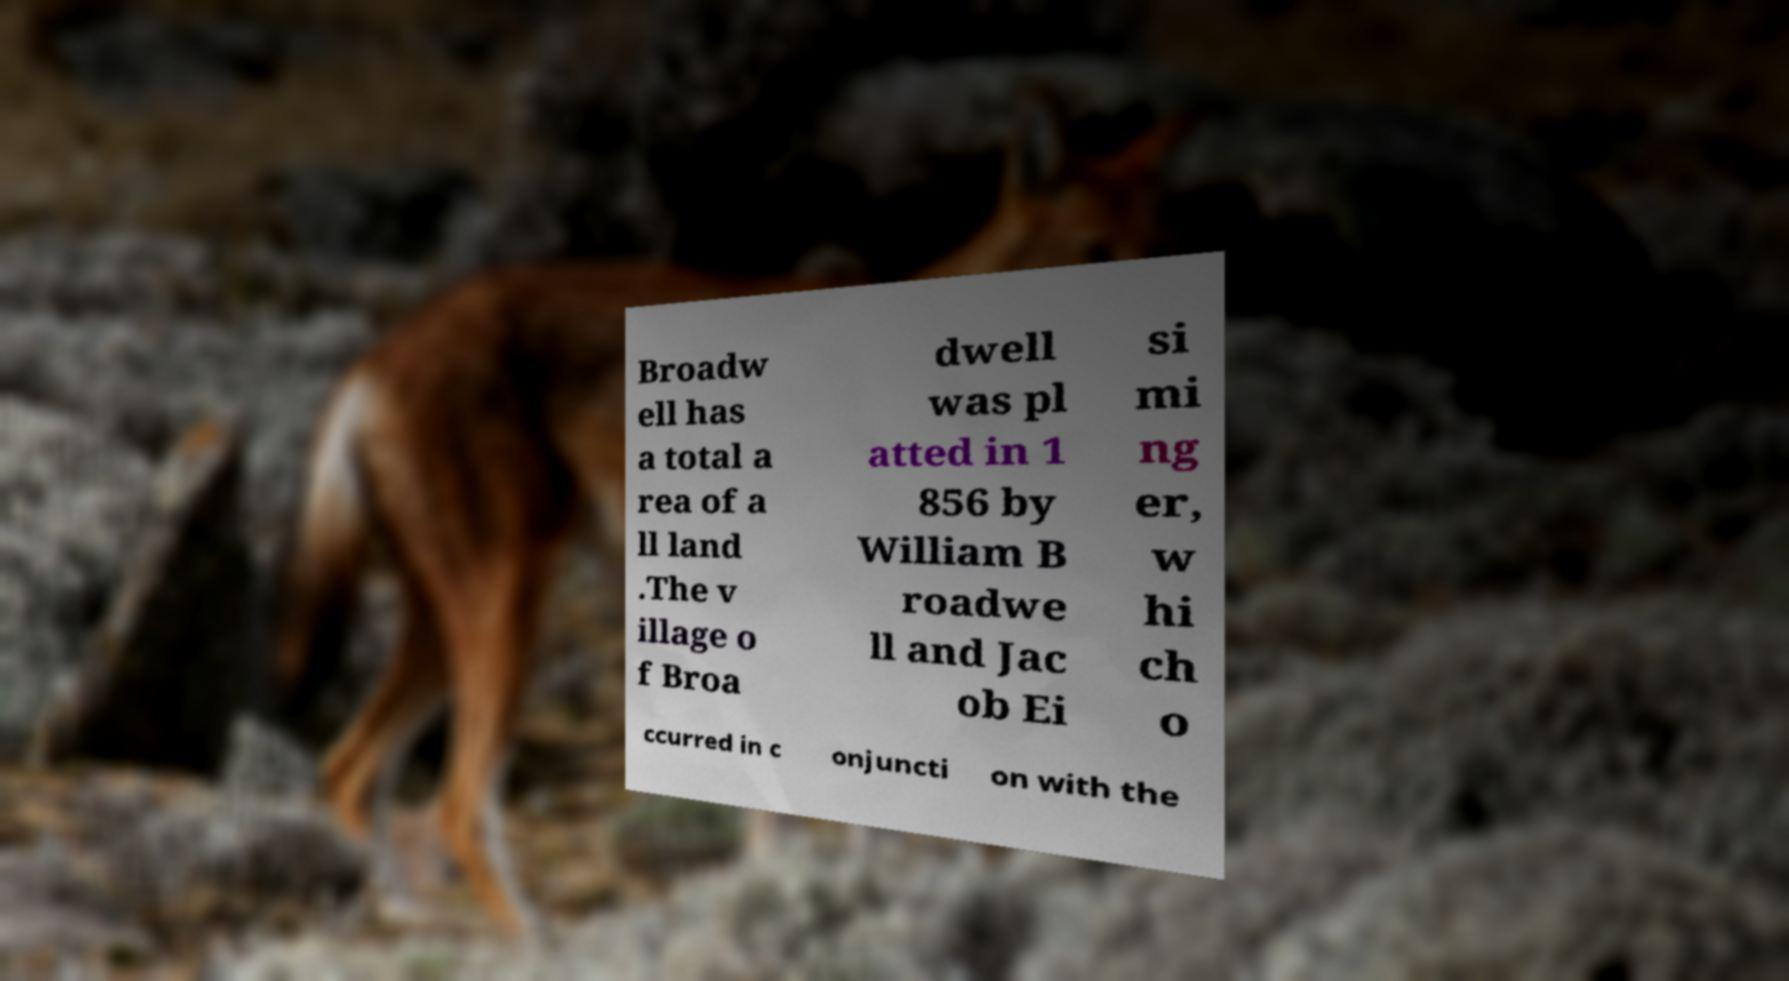Could you extract and type out the text from this image? Broadw ell has a total a rea of a ll land .The v illage o f Broa dwell was pl atted in 1 856 by William B roadwe ll and Jac ob Ei si mi ng er, w hi ch o ccurred in c onjuncti on with the 